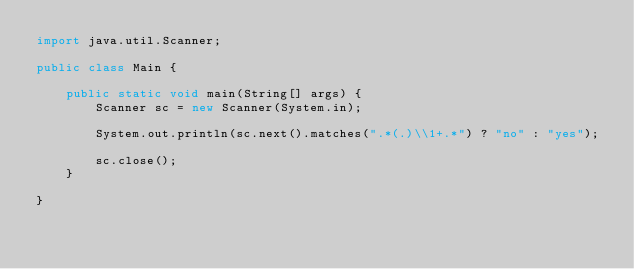Convert code to text. <code><loc_0><loc_0><loc_500><loc_500><_Java_>import java.util.Scanner;

public class Main {

	public static void main(String[] args) {
		Scanner sc = new Scanner(System.in);

		System.out.println(sc.next().matches(".*(.)\\1+.*") ? "no" : "yes");

		sc.close();
	}

}
</code> 